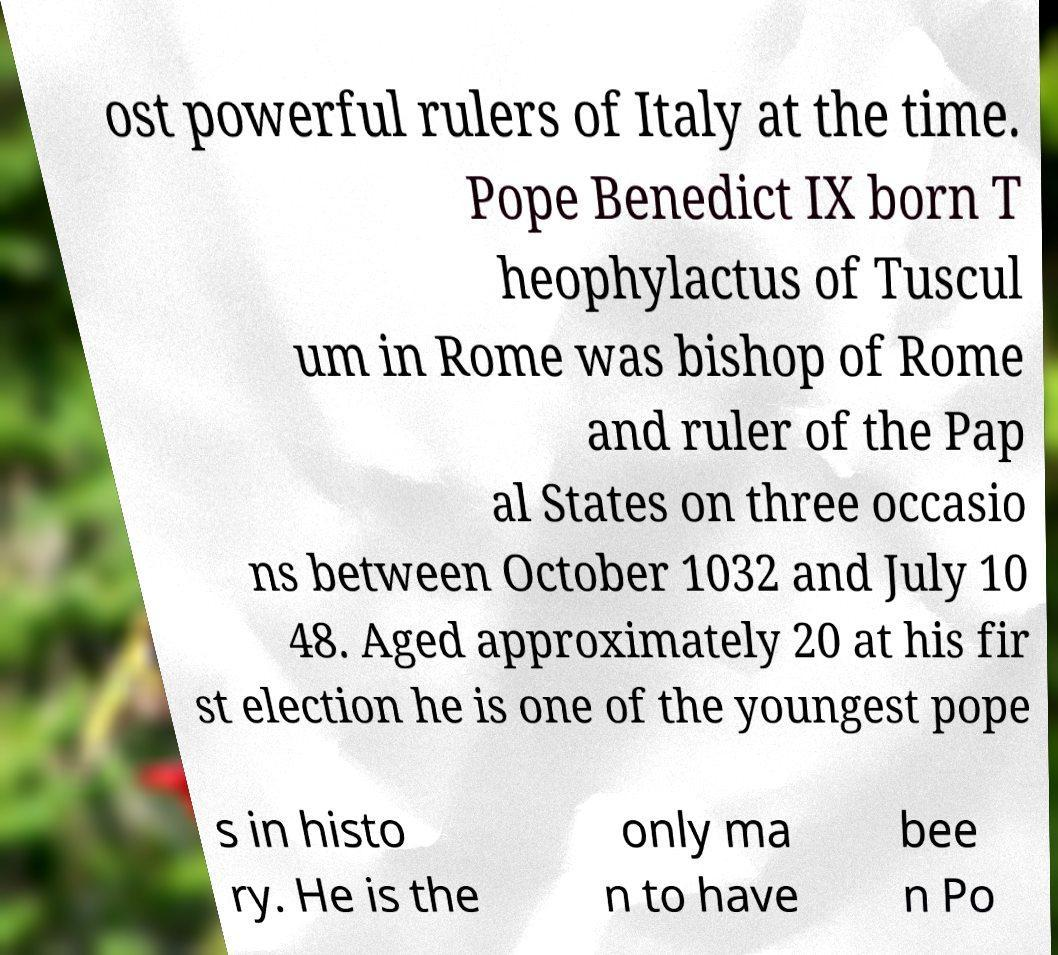There's text embedded in this image that I need extracted. Can you transcribe it verbatim? ost powerful rulers of Italy at the time. Pope Benedict IX born T heophylactus of Tuscul um in Rome was bishop of Rome and ruler of the Pap al States on three occasio ns between October 1032 and July 10 48. Aged approximately 20 at his fir st election he is one of the youngest pope s in histo ry. He is the only ma n to have bee n Po 